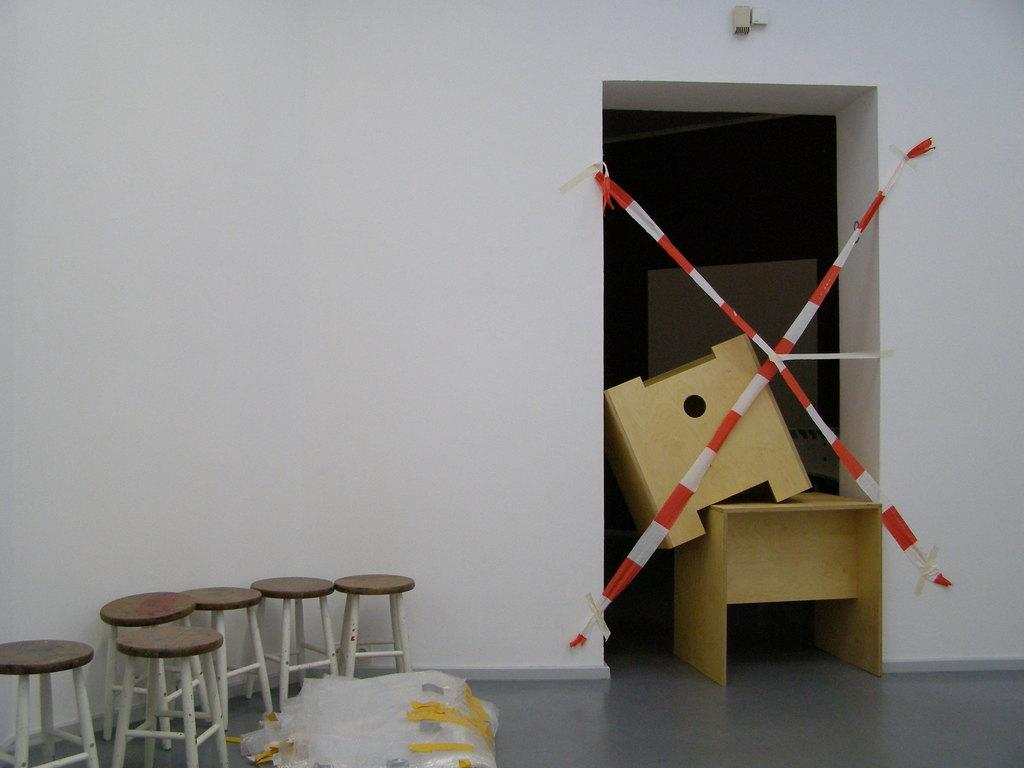What type of furniture is present in the image? There are stools in the image. What is covering the floor in the image? There are covers on the floor. What type of tables can be seen in the image? There are wooden tables in the image. Can you describe the entrance visible in the image? There is an entrance visible in the image. What safety measure is present in the image? Safety tapes are present in the image. What type of wall is visible in the image? There is a plain wall in the image. Is there a rock being read by someone during a rainstorm in the image? No, there is no rock or rainstorm depicted in the image. 